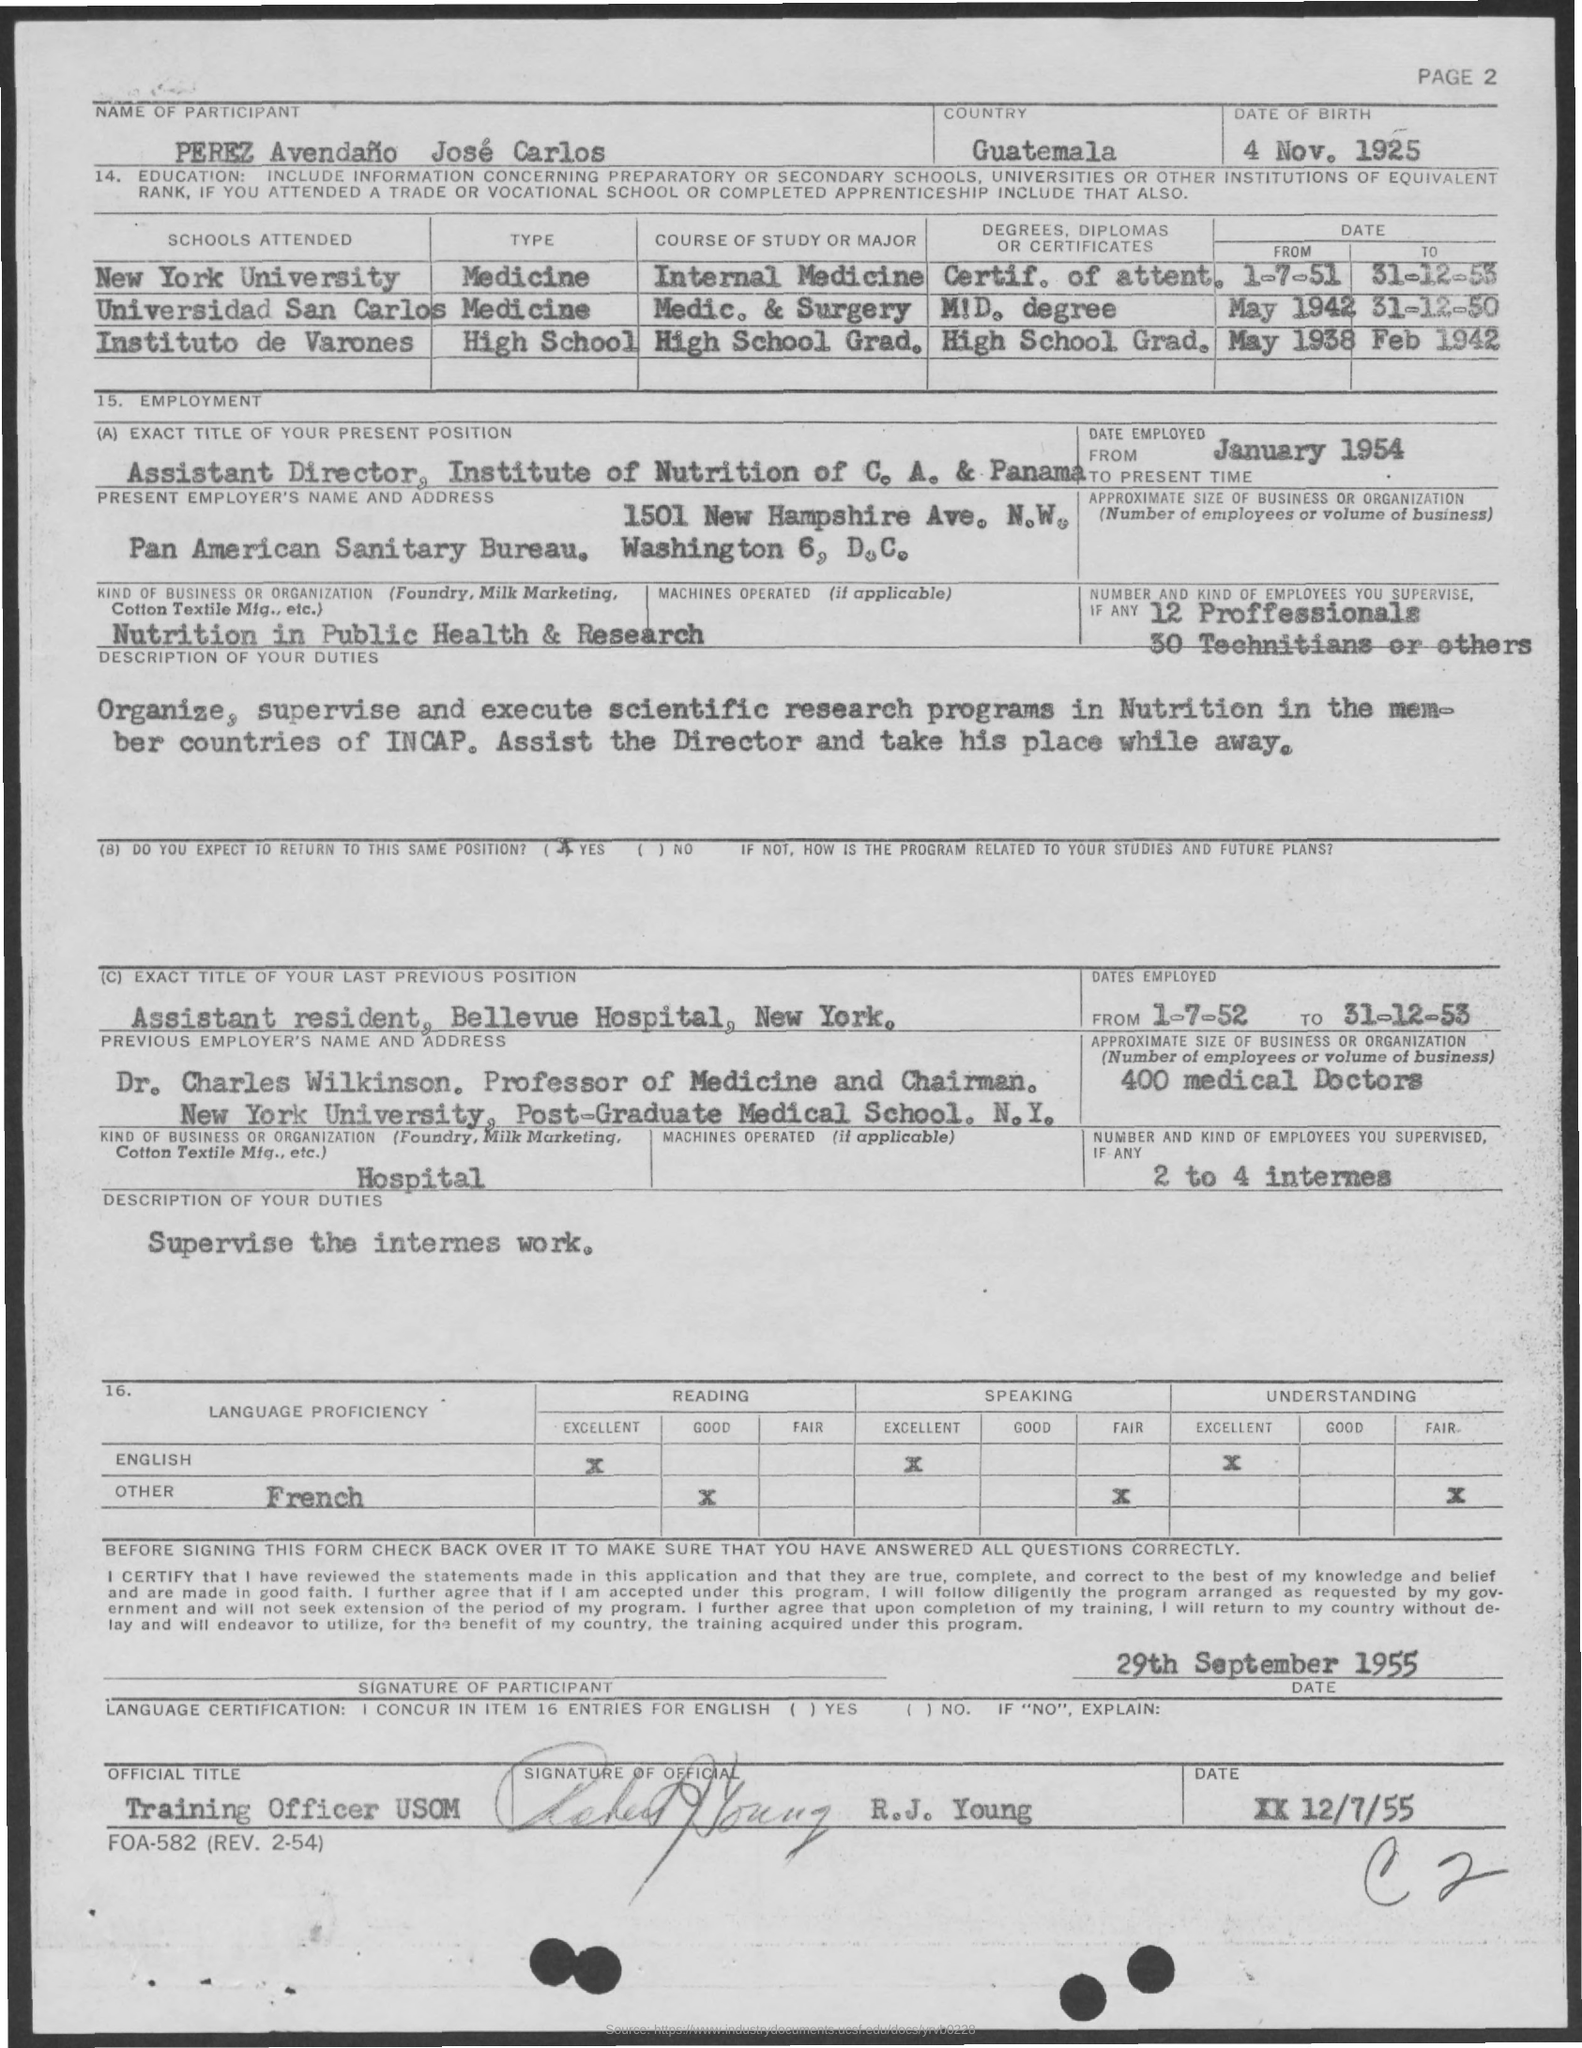Specify some key components in this picture. The individual served as an assistant resident at Bellevue Hospital in New York from July 1st, 1952 to December 31st, 1953. The date of birth as mentioned in the form is November 4, 1925. On January 1954, I was employed as the assistant director at the Institute of Nutrition of C.A. & Panama. There are 12 professionals mentioned in the given form. 